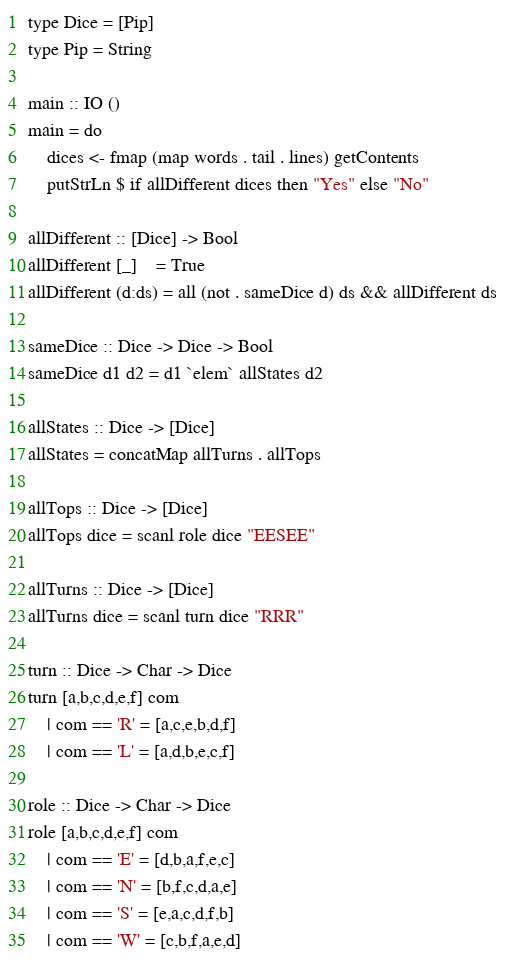Convert code to text. <code><loc_0><loc_0><loc_500><loc_500><_Haskell_>type Dice = [Pip]
type Pip = String

main :: IO ()
main = do
    dices <- fmap (map words . tail . lines) getContents
    putStrLn $ if allDifferent dices then "Yes" else "No"

allDifferent :: [Dice] -> Bool
allDifferent [_]    = True
allDifferent (d:ds) = all (not . sameDice d) ds && allDifferent ds

sameDice :: Dice -> Dice -> Bool
sameDice d1 d2 = d1 `elem` allStates d2

allStates :: Dice -> [Dice]
allStates = concatMap allTurns . allTops

allTops :: Dice -> [Dice]
allTops dice = scanl role dice "EESEE"

allTurns :: Dice -> [Dice]
allTurns dice = scanl turn dice "RRR"

turn :: Dice -> Char -> Dice
turn [a,b,c,d,e,f] com
    | com == 'R' = [a,c,e,b,d,f]
    | com == 'L' = [a,d,b,e,c,f]

role :: Dice -> Char -> Dice
role [a,b,c,d,e,f] com
    | com == 'E' = [d,b,a,f,e,c]
    | com == 'N' = [b,f,c,d,a,e]
    | com == 'S' = [e,a,c,d,f,b]
    | com == 'W' = [c,b,f,a,e,d]
</code> 